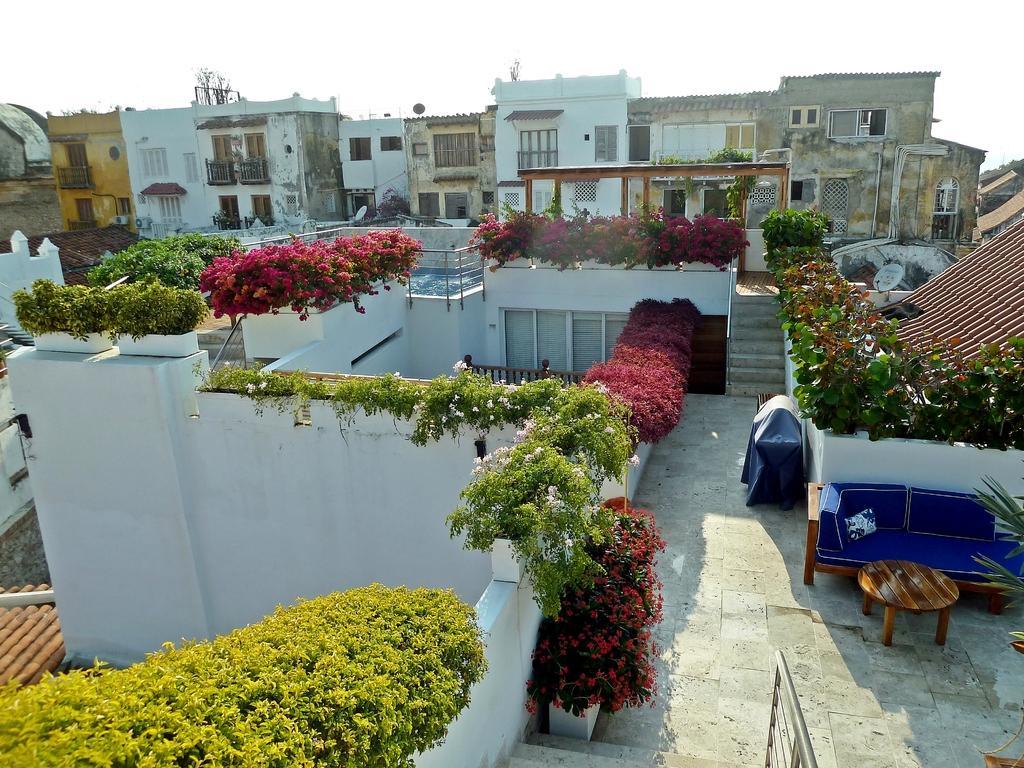Please provide a concise description of this image. In this picture I can see few buildings and I can see few plants and flowers and I can see a sofa and a table and I can see cloudy sky. 